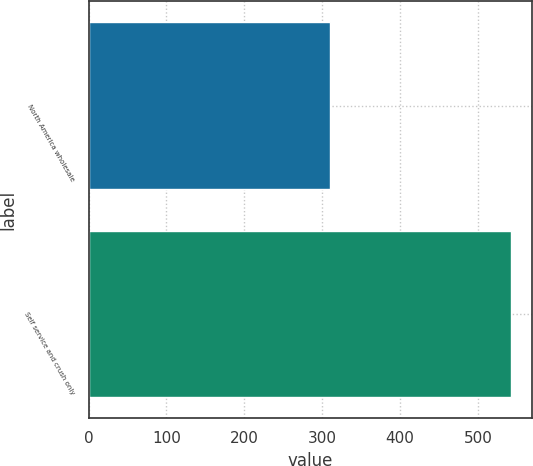Convert chart. <chart><loc_0><loc_0><loc_500><loc_500><bar_chart><fcel>North America wholesale<fcel>Self service and crush only<nl><fcel>310<fcel>542<nl></chart> 